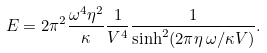<formula> <loc_0><loc_0><loc_500><loc_500>E = 2 \pi ^ { 2 } \frac { \omega ^ { 4 } \eta ^ { 2 } } { \kappa } \frac { 1 } { V ^ { 4 } } \frac { 1 } { \sinh ^ { 2 } ( 2 \pi \eta \, \omega / \kappa V ) } .</formula> 